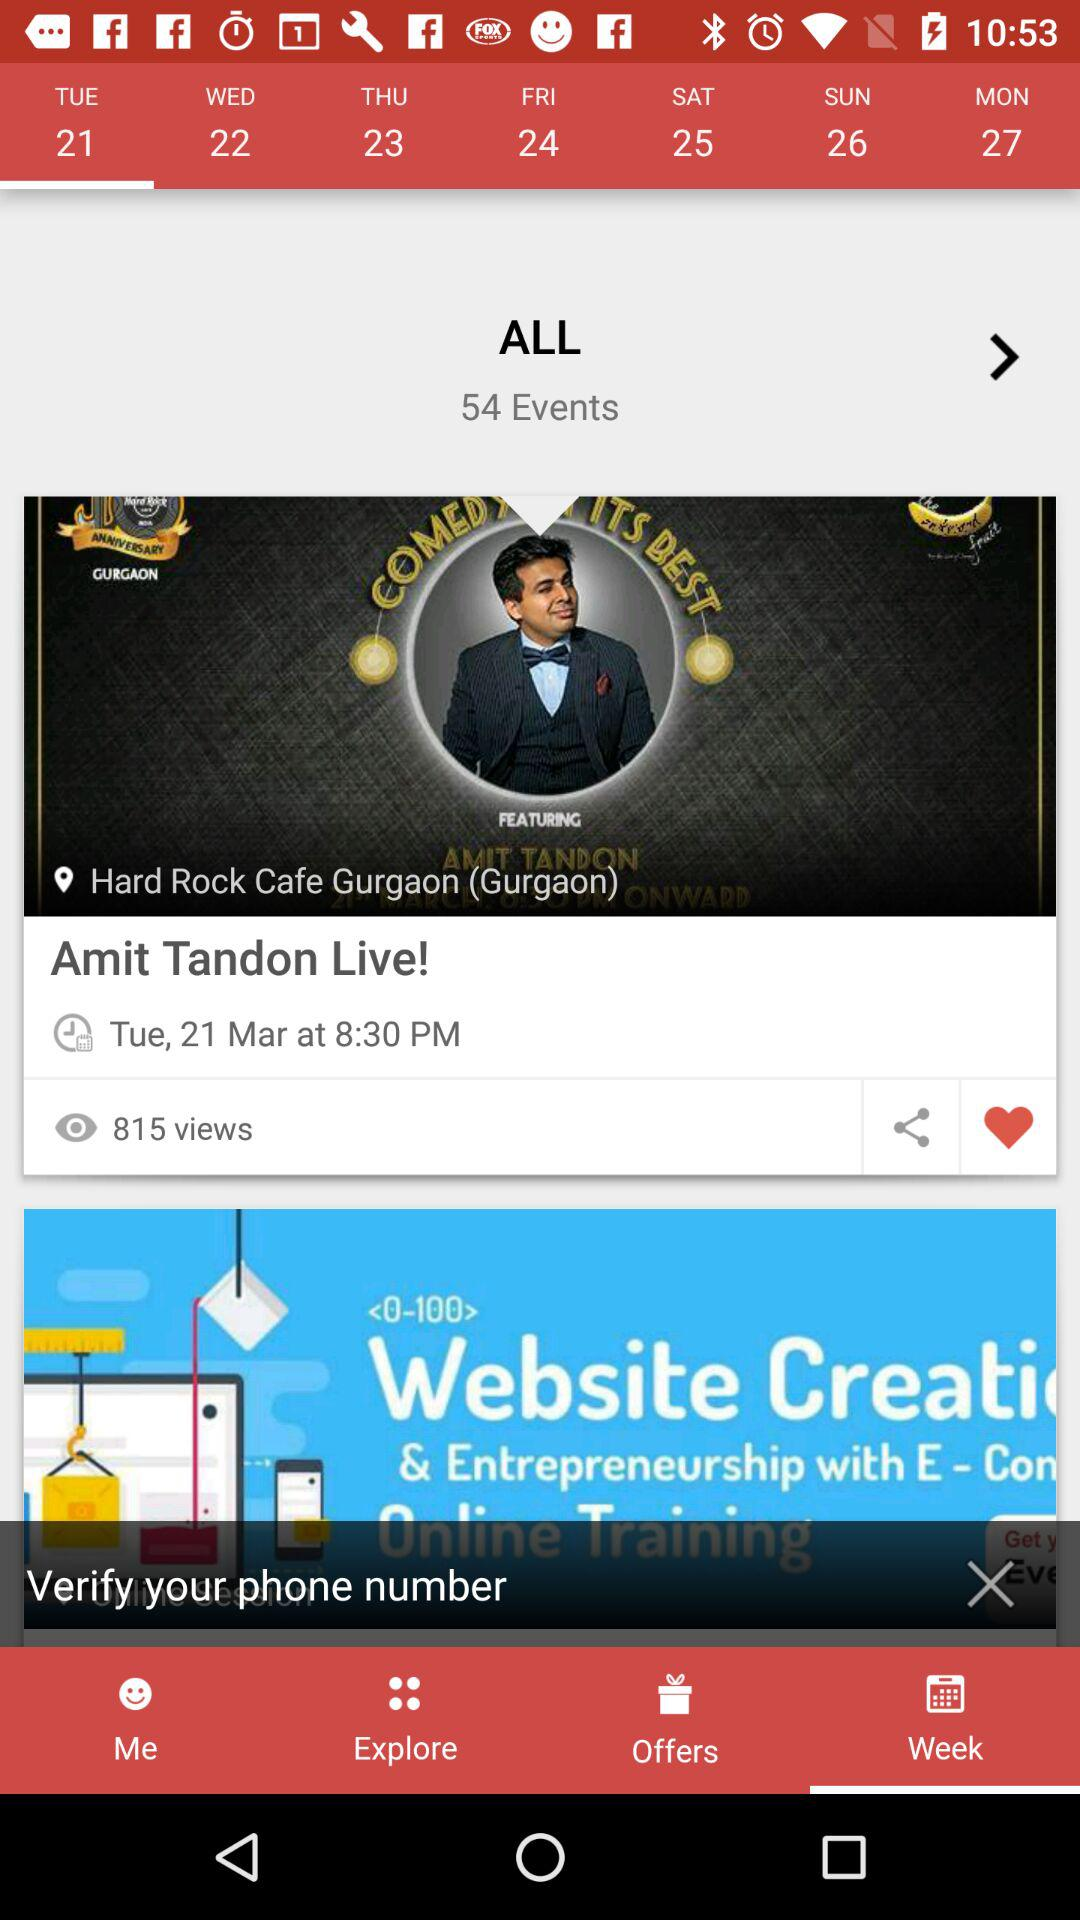How many events are on the calendar?
Answer the question using a single word or phrase. 54 